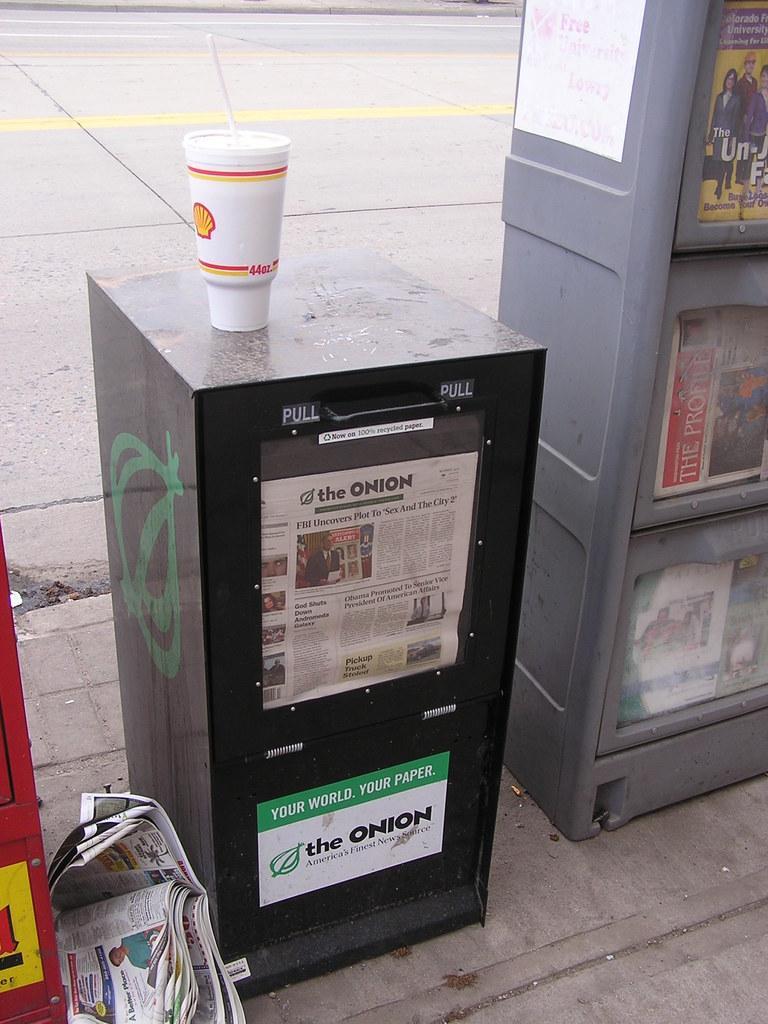Could you give a brief overview of what you see in this image? In this picture we can see a glass with a straw in it, cupboards on the ground, book, posters and in the background we can see the road. 